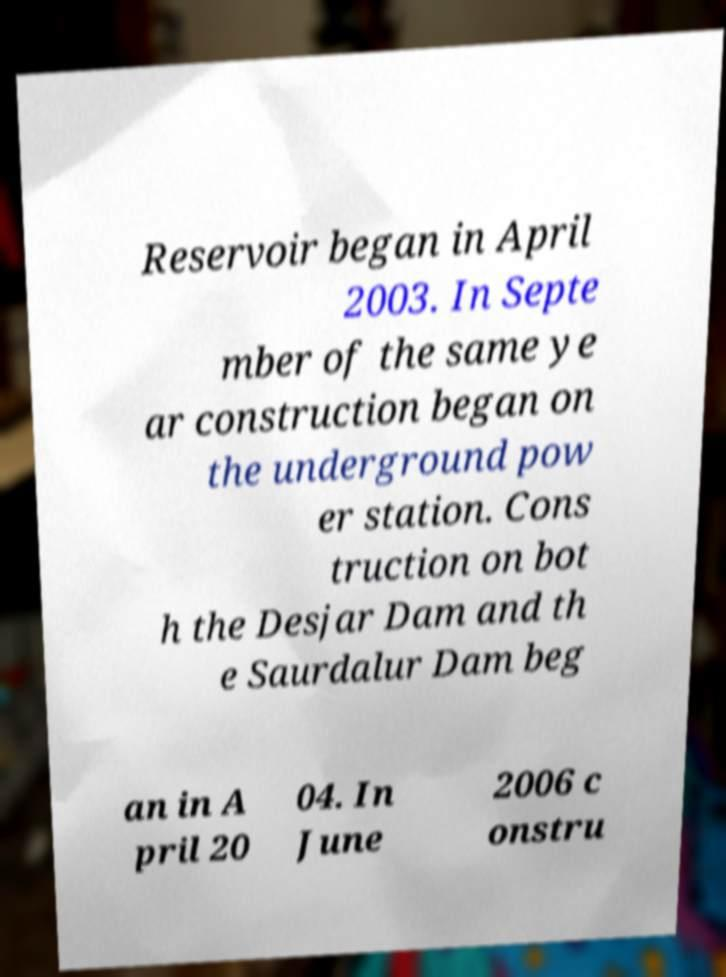I need the written content from this picture converted into text. Can you do that? Reservoir began in April 2003. In Septe mber of the same ye ar construction began on the underground pow er station. Cons truction on bot h the Desjar Dam and th e Saurdalur Dam beg an in A pril 20 04. In June 2006 c onstru 